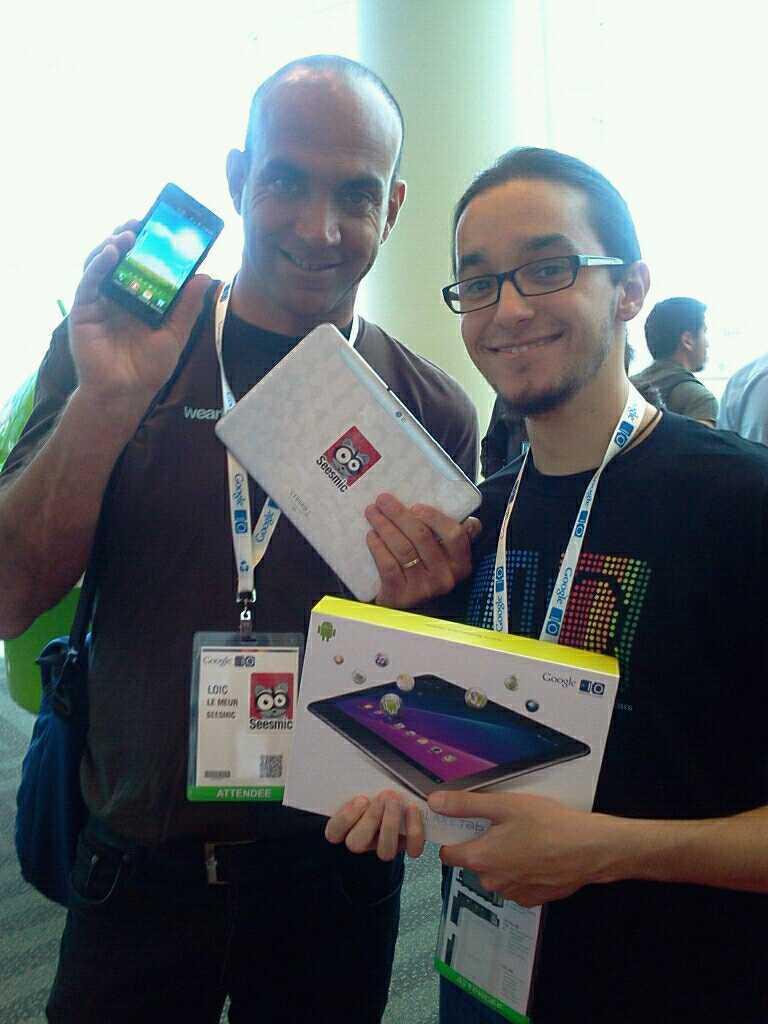Can you describe this image briefly? In the center of the image there are two persons wearing Id card and holding some objects in their hands. In the background of the image there is a pillar and people. 